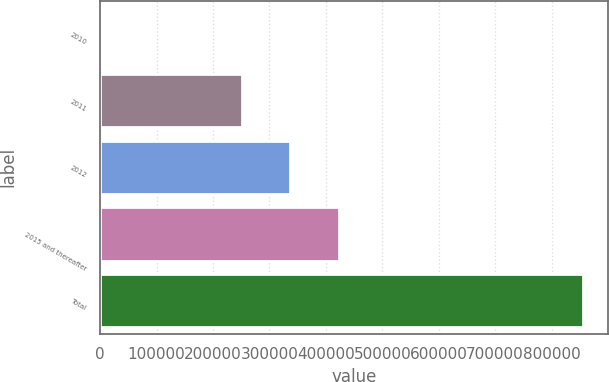<chart> <loc_0><loc_0><loc_500><loc_500><bar_chart><fcel>2010<fcel>2011<fcel>2012<fcel>2015 and thereafter<fcel>Total<nl><fcel>1905<fcel>251528<fcel>337002<fcel>422477<fcel>856650<nl></chart> 